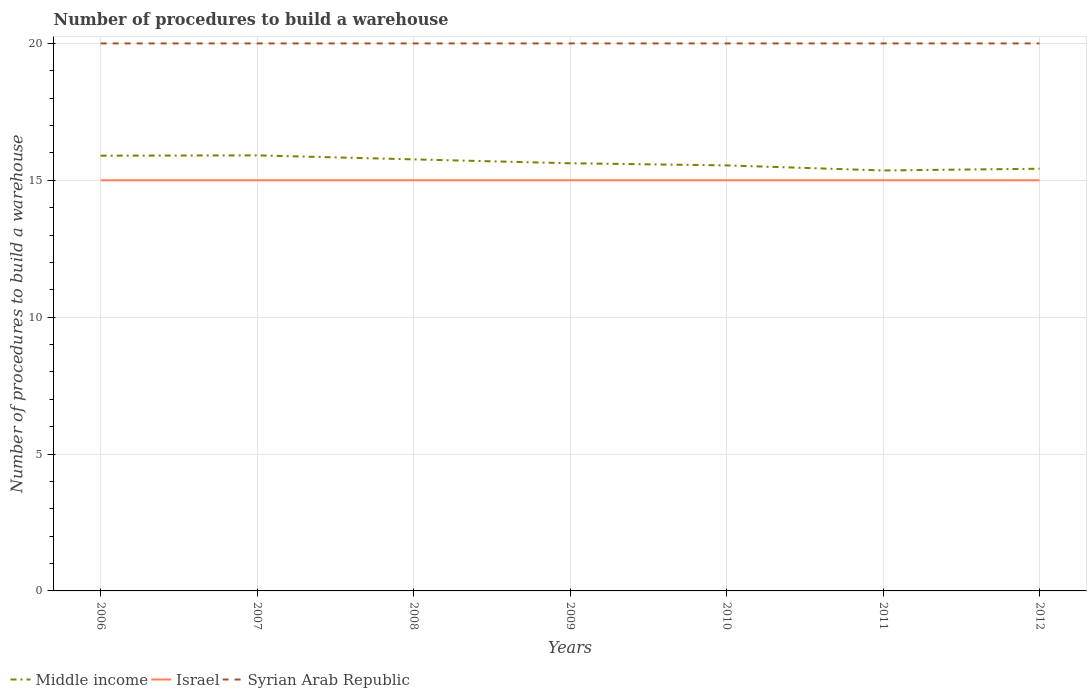Is the number of lines equal to the number of legend labels?
Ensure brevity in your answer.  Yes. Across all years, what is the maximum number of procedures to build a warehouse in in Israel?
Make the answer very short. 15. In which year was the number of procedures to build a warehouse in in Israel maximum?
Offer a terse response. 2006. What is the total number of procedures to build a warehouse in in Middle income in the graph?
Your answer should be very brief. -0.01. Is the number of procedures to build a warehouse in in Syrian Arab Republic strictly greater than the number of procedures to build a warehouse in in Israel over the years?
Your answer should be compact. No. What is the difference between two consecutive major ticks on the Y-axis?
Your response must be concise. 5. Does the graph contain grids?
Ensure brevity in your answer.  Yes. How are the legend labels stacked?
Ensure brevity in your answer.  Horizontal. What is the title of the graph?
Keep it short and to the point. Number of procedures to build a warehouse. What is the label or title of the Y-axis?
Offer a terse response. Number of procedures to build a warehouse. What is the Number of procedures to build a warehouse in Middle income in 2006?
Provide a short and direct response. 15.9. What is the Number of procedures to build a warehouse in Israel in 2006?
Keep it short and to the point. 15. What is the Number of procedures to build a warehouse in Middle income in 2007?
Give a very brief answer. 15.91. What is the Number of procedures to build a warehouse of Middle income in 2008?
Offer a very short reply. 15.76. What is the Number of procedures to build a warehouse in Middle income in 2009?
Offer a terse response. 15.62. What is the Number of procedures to build a warehouse of Israel in 2009?
Ensure brevity in your answer.  15. What is the Number of procedures to build a warehouse in Syrian Arab Republic in 2009?
Give a very brief answer. 20. What is the Number of procedures to build a warehouse in Middle income in 2010?
Make the answer very short. 15.54. What is the Number of procedures to build a warehouse of Israel in 2010?
Make the answer very short. 15. What is the Number of procedures to build a warehouse in Middle income in 2011?
Offer a terse response. 15.36. What is the Number of procedures to build a warehouse in Syrian Arab Republic in 2011?
Your response must be concise. 20. What is the Number of procedures to build a warehouse of Middle income in 2012?
Provide a short and direct response. 15.42. What is the Number of procedures to build a warehouse of Syrian Arab Republic in 2012?
Give a very brief answer. 20. Across all years, what is the maximum Number of procedures to build a warehouse in Middle income?
Give a very brief answer. 15.91. Across all years, what is the maximum Number of procedures to build a warehouse of Israel?
Keep it short and to the point. 15. Across all years, what is the maximum Number of procedures to build a warehouse of Syrian Arab Republic?
Ensure brevity in your answer.  20. Across all years, what is the minimum Number of procedures to build a warehouse in Middle income?
Ensure brevity in your answer.  15.36. Across all years, what is the minimum Number of procedures to build a warehouse of Israel?
Give a very brief answer. 15. Across all years, what is the minimum Number of procedures to build a warehouse of Syrian Arab Republic?
Your response must be concise. 20. What is the total Number of procedures to build a warehouse of Middle income in the graph?
Give a very brief answer. 109.52. What is the total Number of procedures to build a warehouse of Israel in the graph?
Ensure brevity in your answer.  105. What is the total Number of procedures to build a warehouse in Syrian Arab Republic in the graph?
Your answer should be very brief. 140. What is the difference between the Number of procedures to build a warehouse of Middle income in 2006 and that in 2007?
Offer a terse response. -0.01. What is the difference between the Number of procedures to build a warehouse of Middle income in 2006 and that in 2008?
Provide a succinct answer. 0.13. What is the difference between the Number of procedures to build a warehouse of Israel in 2006 and that in 2008?
Provide a short and direct response. 0. What is the difference between the Number of procedures to build a warehouse in Middle income in 2006 and that in 2009?
Offer a terse response. 0.28. What is the difference between the Number of procedures to build a warehouse in Israel in 2006 and that in 2009?
Give a very brief answer. 0. What is the difference between the Number of procedures to build a warehouse in Middle income in 2006 and that in 2010?
Your answer should be compact. 0.35. What is the difference between the Number of procedures to build a warehouse of Israel in 2006 and that in 2010?
Offer a very short reply. 0. What is the difference between the Number of procedures to build a warehouse of Middle income in 2006 and that in 2011?
Make the answer very short. 0.54. What is the difference between the Number of procedures to build a warehouse of Israel in 2006 and that in 2011?
Your answer should be very brief. 0. What is the difference between the Number of procedures to build a warehouse in Syrian Arab Republic in 2006 and that in 2011?
Provide a short and direct response. 0. What is the difference between the Number of procedures to build a warehouse of Middle income in 2006 and that in 2012?
Ensure brevity in your answer.  0.48. What is the difference between the Number of procedures to build a warehouse of Israel in 2006 and that in 2012?
Offer a terse response. 0. What is the difference between the Number of procedures to build a warehouse of Middle income in 2007 and that in 2008?
Keep it short and to the point. 0.15. What is the difference between the Number of procedures to build a warehouse in Israel in 2007 and that in 2008?
Offer a terse response. 0. What is the difference between the Number of procedures to build a warehouse in Middle income in 2007 and that in 2009?
Make the answer very short. 0.29. What is the difference between the Number of procedures to build a warehouse of Israel in 2007 and that in 2009?
Your answer should be very brief. 0. What is the difference between the Number of procedures to build a warehouse in Syrian Arab Republic in 2007 and that in 2009?
Ensure brevity in your answer.  0. What is the difference between the Number of procedures to build a warehouse of Middle income in 2007 and that in 2010?
Ensure brevity in your answer.  0.37. What is the difference between the Number of procedures to build a warehouse of Israel in 2007 and that in 2010?
Provide a short and direct response. 0. What is the difference between the Number of procedures to build a warehouse of Syrian Arab Republic in 2007 and that in 2010?
Give a very brief answer. 0. What is the difference between the Number of procedures to build a warehouse of Middle income in 2007 and that in 2011?
Ensure brevity in your answer.  0.55. What is the difference between the Number of procedures to build a warehouse in Middle income in 2007 and that in 2012?
Keep it short and to the point. 0.49. What is the difference between the Number of procedures to build a warehouse of Syrian Arab Republic in 2007 and that in 2012?
Offer a very short reply. 0. What is the difference between the Number of procedures to build a warehouse in Middle income in 2008 and that in 2009?
Your answer should be compact. 0.14. What is the difference between the Number of procedures to build a warehouse of Syrian Arab Republic in 2008 and that in 2009?
Your answer should be compact. 0. What is the difference between the Number of procedures to build a warehouse of Middle income in 2008 and that in 2010?
Provide a short and direct response. 0.22. What is the difference between the Number of procedures to build a warehouse of Syrian Arab Republic in 2008 and that in 2010?
Your answer should be compact. 0. What is the difference between the Number of procedures to build a warehouse in Middle income in 2008 and that in 2011?
Offer a terse response. 0.4. What is the difference between the Number of procedures to build a warehouse of Israel in 2008 and that in 2011?
Your answer should be very brief. 0. What is the difference between the Number of procedures to build a warehouse of Syrian Arab Republic in 2008 and that in 2011?
Ensure brevity in your answer.  0. What is the difference between the Number of procedures to build a warehouse in Middle income in 2008 and that in 2012?
Offer a terse response. 0.34. What is the difference between the Number of procedures to build a warehouse in Israel in 2008 and that in 2012?
Your answer should be compact. 0. What is the difference between the Number of procedures to build a warehouse of Middle income in 2009 and that in 2010?
Make the answer very short. 0.08. What is the difference between the Number of procedures to build a warehouse of Israel in 2009 and that in 2010?
Your answer should be very brief. 0. What is the difference between the Number of procedures to build a warehouse in Syrian Arab Republic in 2009 and that in 2010?
Your answer should be very brief. 0. What is the difference between the Number of procedures to build a warehouse in Middle income in 2009 and that in 2011?
Your response must be concise. 0.26. What is the difference between the Number of procedures to build a warehouse in Israel in 2009 and that in 2011?
Your answer should be very brief. 0. What is the difference between the Number of procedures to build a warehouse in Middle income in 2009 and that in 2012?
Make the answer very short. 0.2. What is the difference between the Number of procedures to build a warehouse in Israel in 2009 and that in 2012?
Make the answer very short. 0. What is the difference between the Number of procedures to build a warehouse in Middle income in 2010 and that in 2011?
Provide a succinct answer. 0.18. What is the difference between the Number of procedures to build a warehouse in Israel in 2010 and that in 2011?
Provide a succinct answer. 0. What is the difference between the Number of procedures to build a warehouse in Syrian Arab Republic in 2010 and that in 2011?
Offer a terse response. 0. What is the difference between the Number of procedures to build a warehouse in Middle income in 2010 and that in 2012?
Keep it short and to the point. 0.12. What is the difference between the Number of procedures to build a warehouse of Middle income in 2011 and that in 2012?
Give a very brief answer. -0.06. What is the difference between the Number of procedures to build a warehouse of Middle income in 2006 and the Number of procedures to build a warehouse of Israel in 2007?
Provide a short and direct response. 0.9. What is the difference between the Number of procedures to build a warehouse of Middle income in 2006 and the Number of procedures to build a warehouse of Syrian Arab Republic in 2007?
Make the answer very short. -4.1. What is the difference between the Number of procedures to build a warehouse in Middle income in 2006 and the Number of procedures to build a warehouse in Israel in 2008?
Make the answer very short. 0.9. What is the difference between the Number of procedures to build a warehouse in Middle income in 2006 and the Number of procedures to build a warehouse in Syrian Arab Republic in 2008?
Give a very brief answer. -4.1. What is the difference between the Number of procedures to build a warehouse of Israel in 2006 and the Number of procedures to build a warehouse of Syrian Arab Republic in 2008?
Your answer should be very brief. -5. What is the difference between the Number of procedures to build a warehouse of Middle income in 2006 and the Number of procedures to build a warehouse of Israel in 2009?
Your answer should be very brief. 0.9. What is the difference between the Number of procedures to build a warehouse of Middle income in 2006 and the Number of procedures to build a warehouse of Syrian Arab Republic in 2009?
Provide a short and direct response. -4.1. What is the difference between the Number of procedures to build a warehouse of Middle income in 2006 and the Number of procedures to build a warehouse of Israel in 2010?
Ensure brevity in your answer.  0.9. What is the difference between the Number of procedures to build a warehouse in Middle income in 2006 and the Number of procedures to build a warehouse in Syrian Arab Republic in 2010?
Offer a terse response. -4.1. What is the difference between the Number of procedures to build a warehouse of Israel in 2006 and the Number of procedures to build a warehouse of Syrian Arab Republic in 2010?
Provide a short and direct response. -5. What is the difference between the Number of procedures to build a warehouse in Middle income in 2006 and the Number of procedures to build a warehouse in Israel in 2011?
Your answer should be compact. 0.9. What is the difference between the Number of procedures to build a warehouse of Middle income in 2006 and the Number of procedures to build a warehouse of Syrian Arab Republic in 2011?
Your answer should be very brief. -4.1. What is the difference between the Number of procedures to build a warehouse in Israel in 2006 and the Number of procedures to build a warehouse in Syrian Arab Republic in 2011?
Provide a succinct answer. -5. What is the difference between the Number of procedures to build a warehouse in Middle income in 2006 and the Number of procedures to build a warehouse in Israel in 2012?
Offer a very short reply. 0.9. What is the difference between the Number of procedures to build a warehouse of Middle income in 2006 and the Number of procedures to build a warehouse of Syrian Arab Republic in 2012?
Keep it short and to the point. -4.1. What is the difference between the Number of procedures to build a warehouse in Israel in 2006 and the Number of procedures to build a warehouse in Syrian Arab Republic in 2012?
Give a very brief answer. -5. What is the difference between the Number of procedures to build a warehouse of Middle income in 2007 and the Number of procedures to build a warehouse of Israel in 2008?
Make the answer very short. 0.91. What is the difference between the Number of procedures to build a warehouse in Middle income in 2007 and the Number of procedures to build a warehouse in Syrian Arab Republic in 2008?
Make the answer very short. -4.09. What is the difference between the Number of procedures to build a warehouse in Middle income in 2007 and the Number of procedures to build a warehouse in Israel in 2009?
Provide a short and direct response. 0.91. What is the difference between the Number of procedures to build a warehouse in Middle income in 2007 and the Number of procedures to build a warehouse in Syrian Arab Republic in 2009?
Offer a terse response. -4.09. What is the difference between the Number of procedures to build a warehouse of Israel in 2007 and the Number of procedures to build a warehouse of Syrian Arab Republic in 2009?
Your answer should be compact. -5. What is the difference between the Number of procedures to build a warehouse in Middle income in 2007 and the Number of procedures to build a warehouse in Israel in 2010?
Your response must be concise. 0.91. What is the difference between the Number of procedures to build a warehouse of Middle income in 2007 and the Number of procedures to build a warehouse of Syrian Arab Republic in 2010?
Your answer should be compact. -4.09. What is the difference between the Number of procedures to build a warehouse of Israel in 2007 and the Number of procedures to build a warehouse of Syrian Arab Republic in 2010?
Keep it short and to the point. -5. What is the difference between the Number of procedures to build a warehouse in Middle income in 2007 and the Number of procedures to build a warehouse in Israel in 2011?
Ensure brevity in your answer.  0.91. What is the difference between the Number of procedures to build a warehouse in Middle income in 2007 and the Number of procedures to build a warehouse in Syrian Arab Republic in 2011?
Offer a very short reply. -4.09. What is the difference between the Number of procedures to build a warehouse of Israel in 2007 and the Number of procedures to build a warehouse of Syrian Arab Republic in 2011?
Provide a short and direct response. -5. What is the difference between the Number of procedures to build a warehouse in Middle income in 2007 and the Number of procedures to build a warehouse in Israel in 2012?
Keep it short and to the point. 0.91. What is the difference between the Number of procedures to build a warehouse of Middle income in 2007 and the Number of procedures to build a warehouse of Syrian Arab Republic in 2012?
Your response must be concise. -4.09. What is the difference between the Number of procedures to build a warehouse of Israel in 2007 and the Number of procedures to build a warehouse of Syrian Arab Republic in 2012?
Your response must be concise. -5. What is the difference between the Number of procedures to build a warehouse of Middle income in 2008 and the Number of procedures to build a warehouse of Israel in 2009?
Your answer should be very brief. 0.76. What is the difference between the Number of procedures to build a warehouse in Middle income in 2008 and the Number of procedures to build a warehouse in Syrian Arab Republic in 2009?
Keep it short and to the point. -4.24. What is the difference between the Number of procedures to build a warehouse in Israel in 2008 and the Number of procedures to build a warehouse in Syrian Arab Republic in 2009?
Your response must be concise. -5. What is the difference between the Number of procedures to build a warehouse of Middle income in 2008 and the Number of procedures to build a warehouse of Israel in 2010?
Ensure brevity in your answer.  0.76. What is the difference between the Number of procedures to build a warehouse of Middle income in 2008 and the Number of procedures to build a warehouse of Syrian Arab Republic in 2010?
Provide a short and direct response. -4.24. What is the difference between the Number of procedures to build a warehouse in Middle income in 2008 and the Number of procedures to build a warehouse in Israel in 2011?
Your answer should be very brief. 0.76. What is the difference between the Number of procedures to build a warehouse in Middle income in 2008 and the Number of procedures to build a warehouse in Syrian Arab Republic in 2011?
Offer a terse response. -4.24. What is the difference between the Number of procedures to build a warehouse in Israel in 2008 and the Number of procedures to build a warehouse in Syrian Arab Republic in 2011?
Your answer should be very brief. -5. What is the difference between the Number of procedures to build a warehouse in Middle income in 2008 and the Number of procedures to build a warehouse in Israel in 2012?
Your answer should be very brief. 0.76. What is the difference between the Number of procedures to build a warehouse in Middle income in 2008 and the Number of procedures to build a warehouse in Syrian Arab Republic in 2012?
Offer a very short reply. -4.24. What is the difference between the Number of procedures to build a warehouse of Middle income in 2009 and the Number of procedures to build a warehouse of Israel in 2010?
Make the answer very short. 0.62. What is the difference between the Number of procedures to build a warehouse in Middle income in 2009 and the Number of procedures to build a warehouse in Syrian Arab Republic in 2010?
Offer a terse response. -4.38. What is the difference between the Number of procedures to build a warehouse in Israel in 2009 and the Number of procedures to build a warehouse in Syrian Arab Republic in 2010?
Provide a short and direct response. -5. What is the difference between the Number of procedures to build a warehouse of Middle income in 2009 and the Number of procedures to build a warehouse of Israel in 2011?
Provide a short and direct response. 0.62. What is the difference between the Number of procedures to build a warehouse in Middle income in 2009 and the Number of procedures to build a warehouse in Syrian Arab Republic in 2011?
Ensure brevity in your answer.  -4.38. What is the difference between the Number of procedures to build a warehouse of Israel in 2009 and the Number of procedures to build a warehouse of Syrian Arab Republic in 2011?
Provide a succinct answer. -5. What is the difference between the Number of procedures to build a warehouse in Middle income in 2009 and the Number of procedures to build a warehouse in Israel in 2012?
Ensure brevity in your answer.  0.62. What is the difference between the Number of procedures to build a warehouse of Middle income in 2009 and the Number of procedures to build a warehouse of Syrian Arab Republic in 2012?
Offer a terse response. -4.38. What is the difference between the Number of procedures to build a warehouse in Middle income in 2010 and the Number of procedures to build a warehouse in Israel in 2011?
Give a very brief answer. 0.54. What is the difference between the Number of procedures to build a warehouse of Middle income in 2010 and the Number of procedures to build a warehouse of Syrian Arab Republic in 2011?
Provide a succinct answer. -4.46. What is the difference between the Number of procedures to build a warehouse of Middle income in 2010 and the Number of procedures to build a warehouse of Israel in 2012?
Provide a succinct answer. 0.54. What is the difference between the Number of procedures to build a warehouse of Middle income in 2010 and the Number of procedures to build a warehouse of Syrian Arab Republic in 2012?
Provide a succinct answer. -4.46. What is the difference between the Number of procedures to build a warehouse of Israel in 2010 and the Number of procedures to build a warehouse of Syrian Arab Republic in 2012?
Provide a succinct answer. -5. What is the difference between the Number of procedures to build a warehouse in Middle income in 2011 and the Number of procedures to build a warehouse in Israel in 2012?
Keep it short and to the point. 0.36. What is the difference between the Number of procedures to build a warehouse in Middle income in 2011 and the Number of procedures to build a warehouse in Syrian Arab Republic in 2012?
Your answer should be very brief. -4.64. What is the difference between the Number of procedures to build a warehouse of Israel in 2011 and the Number of procedures to build a warehouse of Syrian Arab Republic in 2012?
Give a very brief answer. -5. What is the average Number of procedures to build a warehouse in Middle income per year?
Ensure brevity in your answer.  15.65. What is the average Number of procedures to build a warehouse in Syrian Arab Republic per year?
Make the answer very short. 20. In the year 2006, what is the difference between the Number of procedures to build a warehouse in Middle income and Number of procedures to build a warehouse in Israel?
Your answer should be compact. 0.9. In the year 2006, what is the difference between the Number of procedures to build a warehouse of Middle income and Number of procedures to build a warehouse of Syrian Arab Republic?
Offer a terse response. -4.1. In the year 2007, what is the difference between the Number of procedures to build a warehouse in Middle income and Number of procedures to build a warehouse in Israel?
Keep it short and to the point. 0.91. In the year 2007, what is the difference between the Number of procedures to build a warehouse of Middle income and Number of procedures to build a warehouse of Syrian Arab Republic?
Offer a very short reply. -4.09. In the year 2008, what is the difference between the Number of procedures to build a warehouse of Middle income and Number of procedures to build a warehouse of Israel?
Your answer should be very brief. 0.76. In the year 2008, what is the difference between the Number of procedures to build a warehouse of Middle income and Number of procedures to build a warehouse of Syrian Arab Republic?
Make the answer very short. -4.24. In the year 2008, what is the difference between the Number of procedures to build a warehouse in Israel and Number of procedures to build a warehouse in Syrian Arab Republic?
Offer a terse response. -5. In the year 2009, what is the difference between the Number of procedures to build a warehouse in Middle income and Number of procedures to build a warehouse in Israel?
Keep it short and to the point. 0.62. In the year 2009, what is the difference between the Number of procedures to build a warehouse in Middle income and Number of procedures to build a warehouse in Syrian Arab Republic?
Provide a succinct answer. -4.38. In the year 2010, what is the difference between the Number of procedures to build a warehouse of Middle income and Number of procedures to build a warehouse of Israel?
Give a very brief answer. 0.54. In the year 2010, what is the difference between the Number of procedures to build a warehouse of Middle income and Number of procedures to build a warehouse of Syrian Arab Republic?
Ensure brevity in your answer.  -4.46. In the year 2010, what is the difference between the Number of procedures to build a warehouse of Israel and Number of procedures to build a warehouse of Syrian Arab Republic?
Make the answer very short. -5. In the year 2011, what is the difference between the Number of procedures to build a warehouse in Middle income and Number of procedures to build a warehouse in Israel?
Your answer should be very brief. 0.36. In the year 2011, what is the difference between the Number of procedures to build a warehouse of Middle income and Number of procedures to build a warehouse of Syrian Arab Republic?
Provide a succinct answer. -4.64. In the year 2011, what is the difference between the Number of procedures to build a warehouse of Israel and Number of procedures to build a warehouse of Syrian Arab Republic?
Make the answer very short. -5. In the year 2012, what is the difference between the Number of procedures to build a warehouse in Middle income and Number of procedures to build a warehouse in Israel?
Your answer should be compact. 0.42. In the year 2012, what is the difference between the Number of procedures to build a warehouse in Middle income and Number of procedures to build a warehouse in Syrian Arab Republic?
Give a very brief answer. -4.58. What is the ratio of the Number of procedures to build a warehouse in Middle income in 2006 to that in 2007?
Your answer should be very brief. 1. What is the ratio of the Number of procedures to build a warehouse in Israel in 2006 to that in 2007?
Your answer should be very brief. 1. What is the ratio of the Number of procedures to build a warehouse of Middle income in 2006 to that in 2008?
Keep it short and to the point. 1.01. What is the ratio of the Number of procedures to build a warehouse in Middle income in 2006 to that in 2009?
Keep it short and to the point. 1.02. What is the ratio of the Number of procedures to build a warehouse of Syrian Arab Republic in 2006 to that in 2009?
Offer a very short reply. 1. What is the ratio of the Number of procedures to build a warehouse in Middle income in 2006 to that in 2010?
Provide a succinct answer. 1.02. What is the ratio of the Number of procedures to build a warehouse of Israel in 2006 to that in 2010?
Your response must be concise. 1. What is the ratio of the Number of procedures to build a warehouse in Middle income in 2006 to that in 2011?
Give a very brief answer. 1.04. What is the ratio of the Number of procedures to build a warehouse in Middle income in 2006 to that in 2012?
Ensure brevity in your answer.  1.03. What is the ratio of the Number of procedures to build a warehouse of Israel in 2006 to that in 2012?
Your response must be concise. 1. What is the ratio of the Number of procedures to build a warehouse of Syrian Arab Republic in 2006 to that in 2012?
Ensure brevity in your answer.  1. What is the ratio of the Number of procedures to build a warehouse in Middle income in 2007 to that in 2008?
Provide a short and direct response. 1.01. What is the ratio of the Number of procedures to build a warehouse in Israel in 2007 to that in 2008?
Make the answer very short. 1. What is the ratio of the Number of procedures to build a warehouse of Middle income in 2007 to that in 2009?
Ensure brevity in your answer.  1.02. What is the ratio of the Number of procedures to build a warehouse of Syrian Arab Republic in 2007 to that in 2009?
Your answer should be very brief. 1. What is the ratio of the Number of procedures to build a warehouse of Middle income in 2007 to that in 2010?
Provide a short and direct response. 1.02. What is the ratio of the Number of procedures to build a warehouse in Israel in 2007 to that in 2010?
Your answer should be compact. 1. What is the ratio of the Number of procedures to build a warehouse in Syrian Arab Republic in 2007 to that in 2010?
Your answer should be very brief. 1. What is the ratio of the Number of procedures to build a warehouse in Middle income in 2007 to that in 2011?
Offer a very short reply. 1.04. What is the ratio of the Number of procedures to build a warehouse in Syrian Arab Republic in 2007 to that in 2011?
Provide a short and direct response. 1. What is the ratio of the Number of procedures to build a warehouse in Middle income in 2007 to that in 2012?
Provide a short and direct response. 1.03. What is the ratio of the Number of procedures to build a warehouse in Israel in 2007 to that in 2012?
Give a very brief answer. 1. What is the ratio of the Number of procedures to build a warehouse in Middle income in 2008 to that in 2009?
Your response must be concise. 1.01. What is the ratio of the Number of procedures to build a warehouse of Israel in 2008 to that in 2009?
Keep it short and to the point. 1. What is the ratio of the Number of procedures to build a warehouse in Middle income in 2008 to that in 2010?
Ensure brevity in your answer.  1.01. What is the ratio of the Number of procedures to build a warehouse of Israel in 2008 to that in 2010?
Your answer should be very brief. 1. What is the ratio of the Number of procedures to build a warehouse of Syrian Arab Republic in 2008 to that in 2010?
Offer a terse response. 1. What is the ratio of the Number of procedures to build a warehouse of Middle income in 2008 to that in 2011?
Keep it short and to the point. 1.03. What is the ratio of the Number of procedures to build a warehouse in Israel in 2008 to that in 2011?
Offer a very short reply. 1. What is the ratio of the Number of procedures to build a warehouse of Middle income in 2008 to that in 2012?
Give a very brief answer. 1.02. What is the ratio of the Number of procedures to build a warehouse in Israel in 2008 to that in 2012?
Keep it short and to the point. 1. What is the ratio of the Number of procedures to build a warehouse in Syrian Arab Republic in 2008 to that in 2012?
Your answer should be compact. 1. What is the ratio of the Number of procedures to build a warehouse in Middle income in 2009 to that in 2010?
Give a very brief answer. 1. What is the ratio of the Number of procedures to build a warehouse in Middle income in 2009 to that in 2011?
Ensure brevity in your answer.  1.02. What is the ratio of the Number of procedures to build a warehouse of Israel in 2009 to that in 2011?
Your answer should be very brief. 1. What is the ratio of the Number of procedures to build a warehouse in Syrian Arab Republic in 2009 to that in 2012?
Offer a terse response. 1. What is the ratio of the Number of procedures to build a warehouse in Middle income in 2010 to that in 2011?
Give a very brief answer. 1.01. What is the ratio of the Number of procedures to build a warehouse in Syrian Arab Republic in 2010 to that in 2011?
Give a very brief answer. 1. What is the ratio of the Number of procedures to build a warehouse in Middle income in 2010 to that in 2012?
Your answer should be compact. 1.01. What is the ratio of the Number of procedures to build a warehouse in Israel in 2010 to that in 2012?
Your answer should be compact. 1. What is the ratio of the Number of procedures to build a warehouse of Syrian Arab Republic in 2010 to that in 2012?
Ensure brevity in your answer.  1. What is the ratio of the Number of procedures to build a warehouse of Middle income in 2011 to that in 2012?
Provide a short and direct response. 1. What is the ratio of the Number of procedures to build a warehouse of Israel in 2011 to that in 2012?
Provide a succinct answer. 1. What is the difference between the highest and the second highest Number of procedures to build a warehouse in Middle income?
Offer a terse response. 0.01. What is the difference between the highest and the lowest Number of procedures to build a warehouse of Middle income?
Keep it short and to the point. 0.55. What is the difference between the highest and the lowest Number of procedures to build a warehouse of Syrian Arab Republic?
Your response must be concise. 0. 